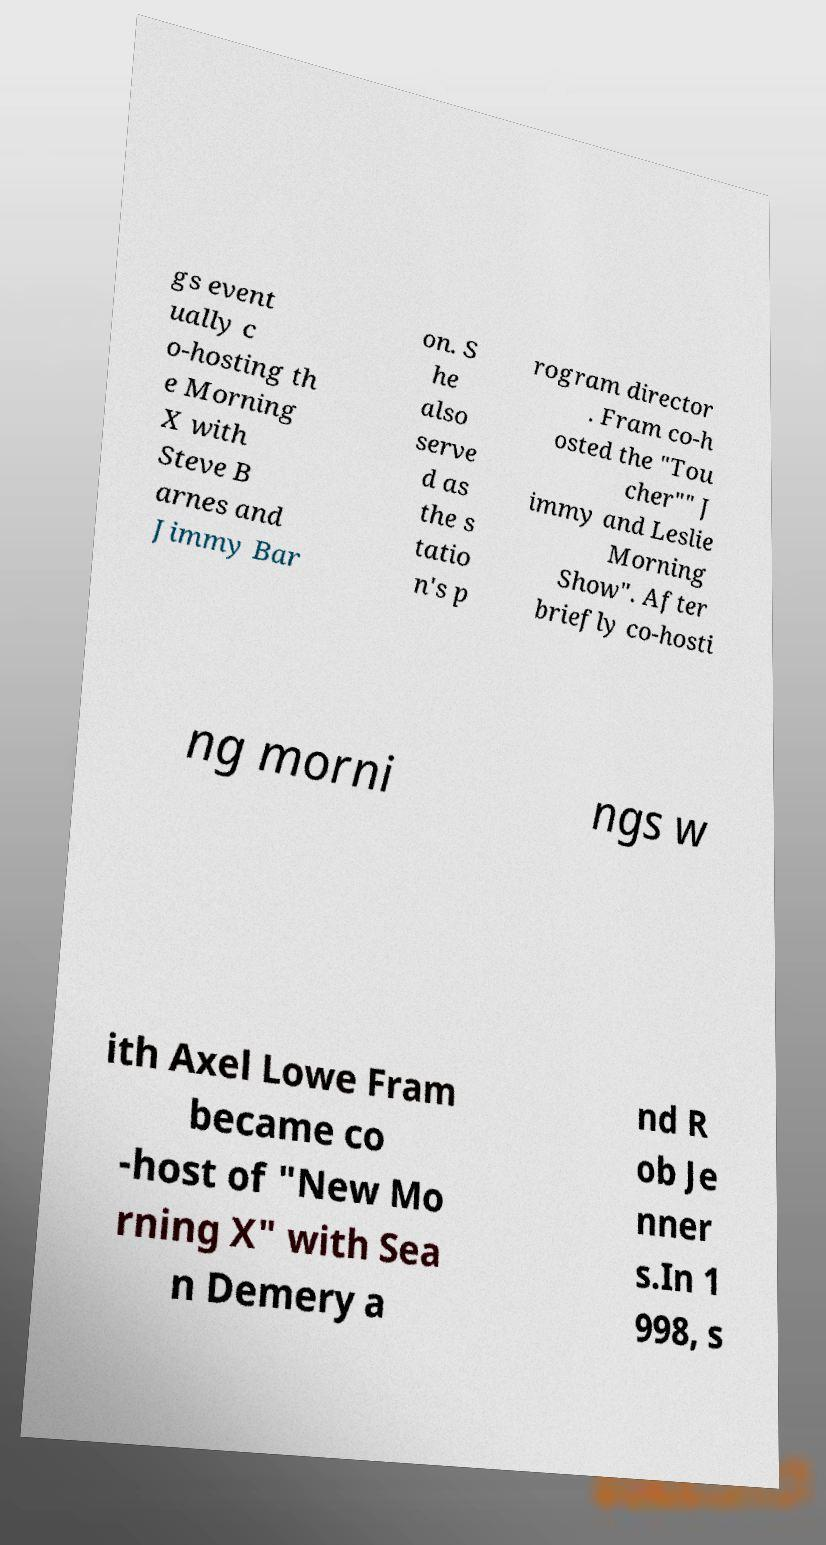Could you assist in decoding the text presented in this image and type it out clearly? gs event ually c o-hosting th e Morning X with Steve B arnes and Jimmy Bar on. S he also serve d as the s tatio n's p rogram director . Fram co-h osted the "Tou cher"" J immy and Leslie Morning Show". After briefly co-hosti ng morni ngs w ith Axel Lowe Fram became co -host of "New Mo rning X" with Sea n Demery a nd R ob Je nner s.In 1 998, s 